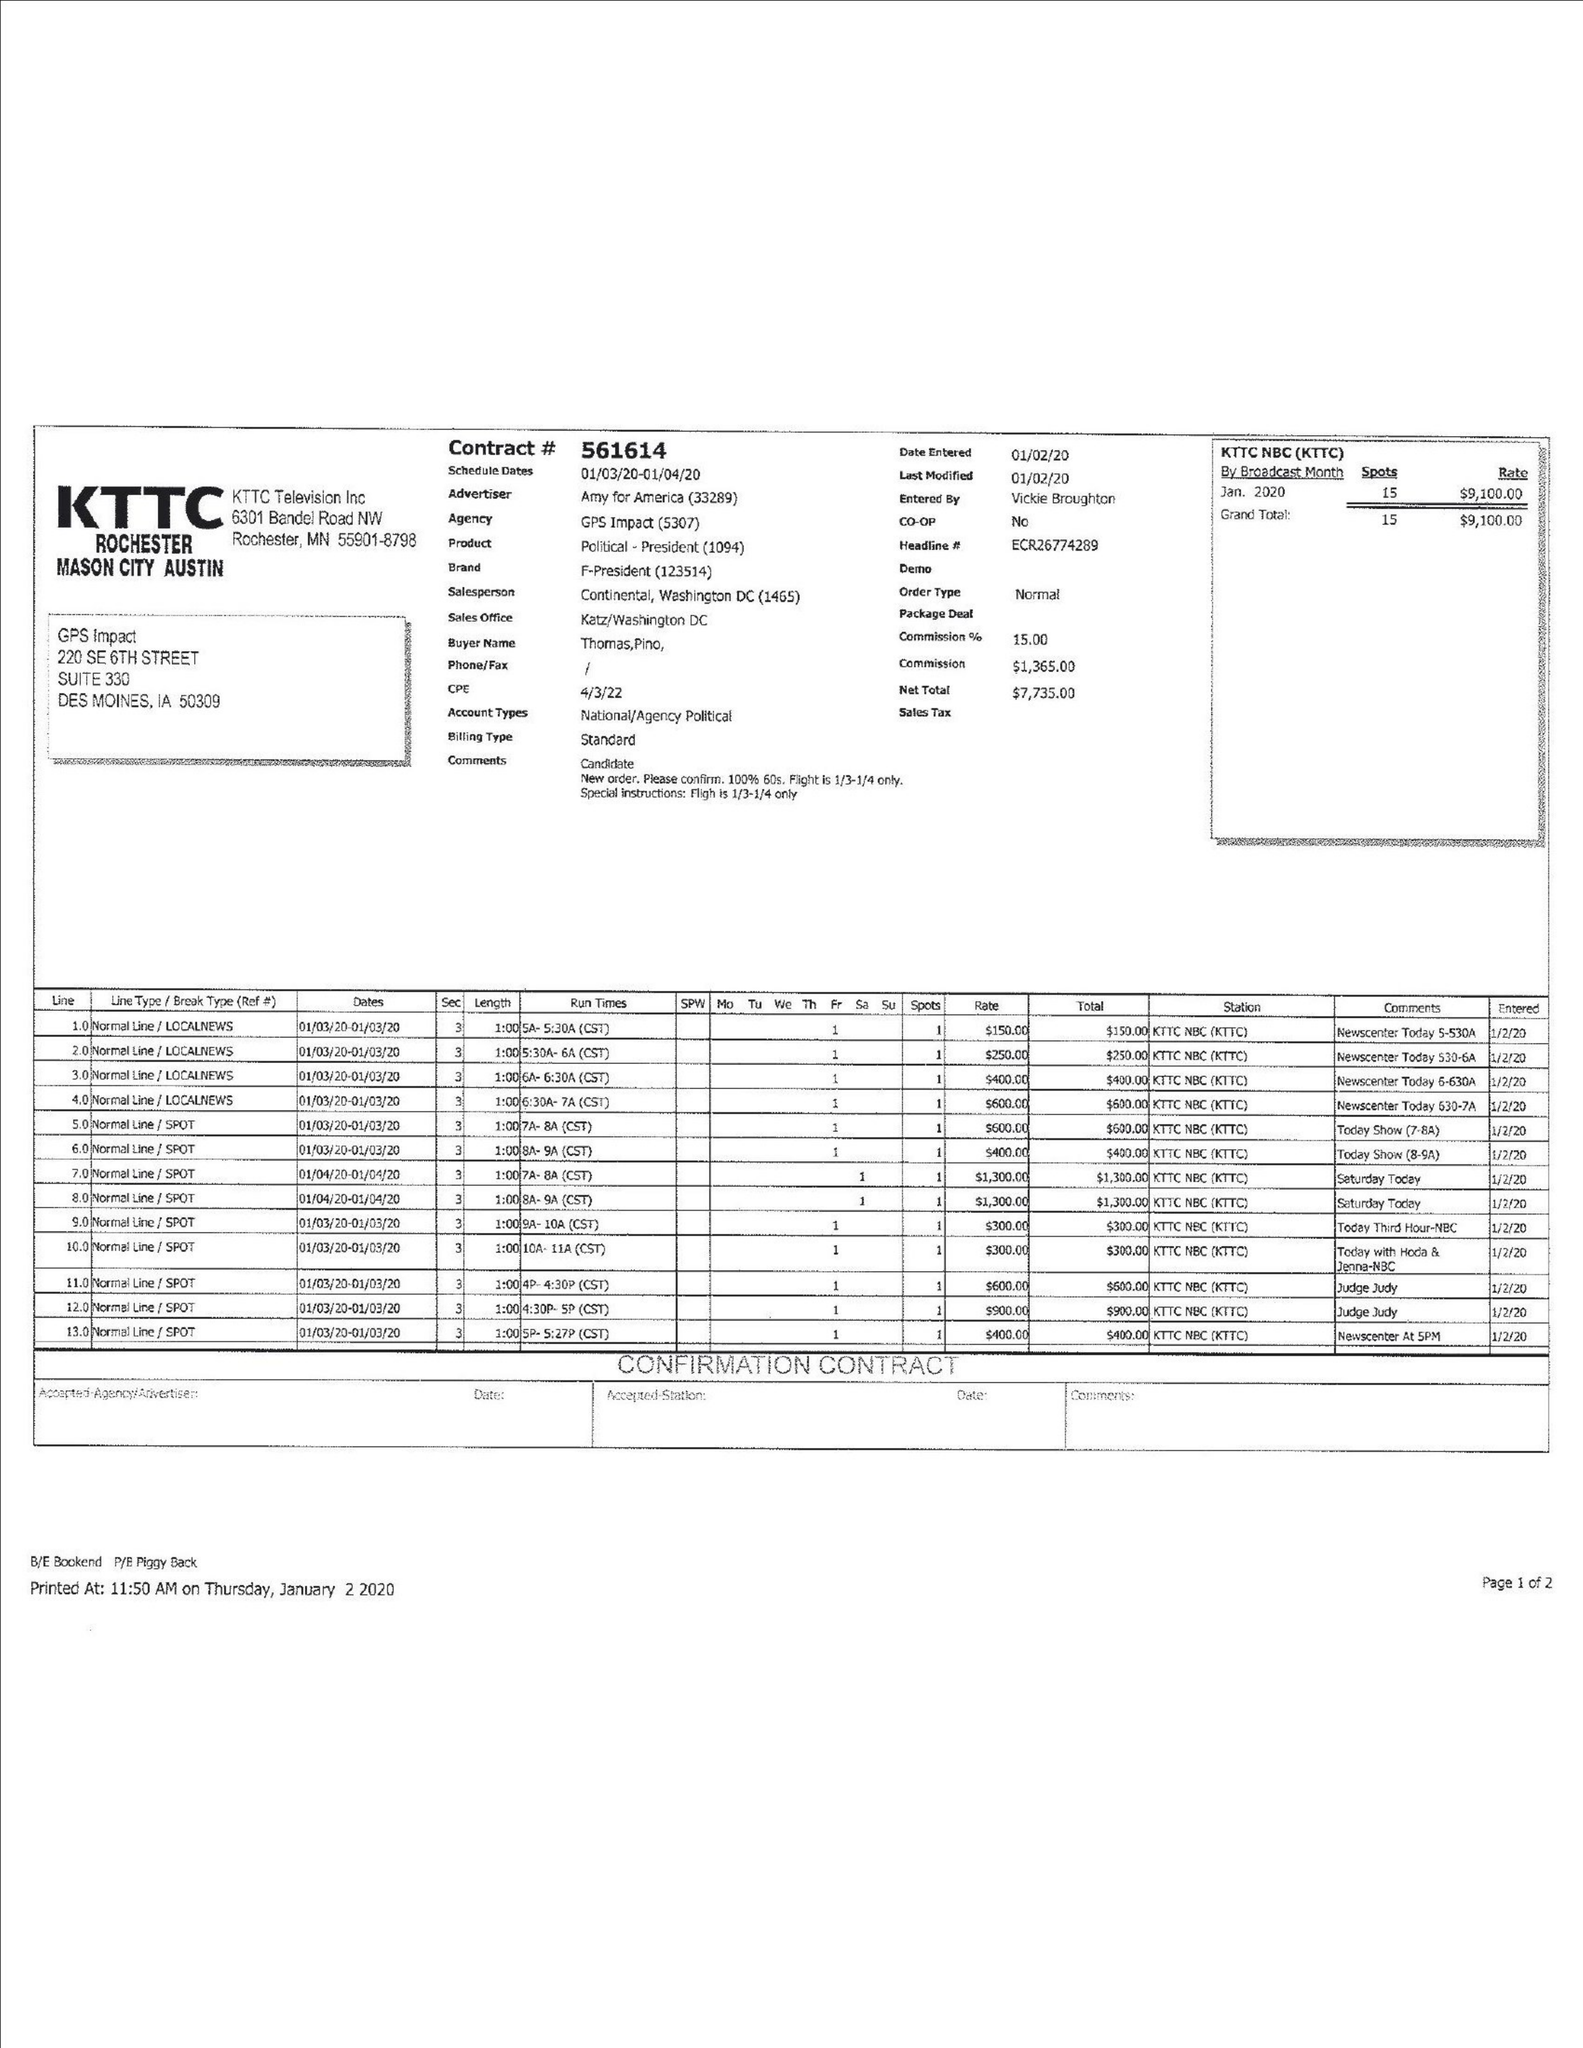What is the value for the gross_amount?
Answer the question using a single word or phrase. 9100.00 